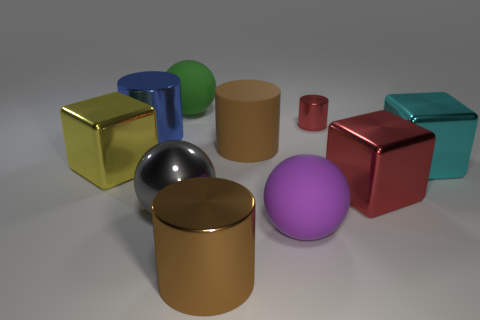Subtract all spheres. How many objects are left? 7 Add 3 small red cylinders. How many small red cylinders are left? 4 Add 7 large red metallic objects. How many large red metallic objects exist? 8 Subtract 0 gray cylinders. How many objects are left? 10 Subtract all yellow matte things. Subtract all cyan objects. How many objects are left? 9 